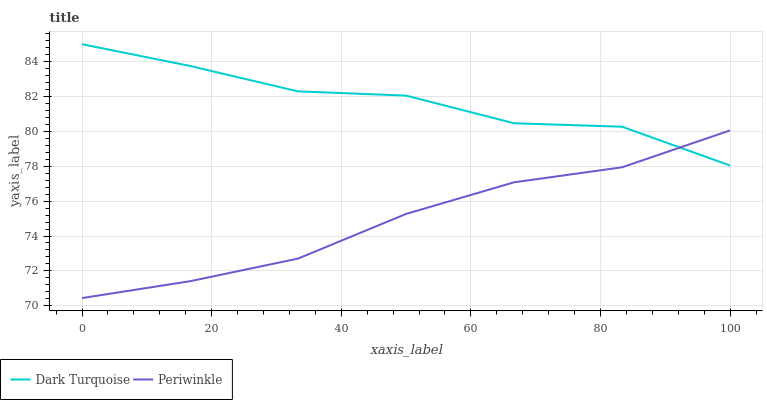Does Periwinkle have the minimum area under the curve?
Answer yes or no. Yes. Does Dark Turquoise have the maximum area under the curve?
Answer yes or no. Yes. Does Periwinkle have the maximum area under the curve?
Answer yes or no. No. Is Periwinkle the smoothest?
Answer yes or no. Yes. Is Dark Turquoise the roughest?
Answer yes or no. Yes. Is Periwinkle the roughest?
Answer yes or no. No. Does Periwinkle have the lowest value?
Answer yes or no. Yes. Does Dark Turquoise have the highest value?
Answer yes or no. Yes. Does Periwinkle have the highest value?
Answer yes or no. No. Does Periwinkle intersect Dark Turquoise?
Answer yes or no. Yes. Is Periwinkle less than Dark Turquoise?
Answer yes or no. No. Is Periwinkle greater than Dark Turquoise?
Answer yes or no. No. 